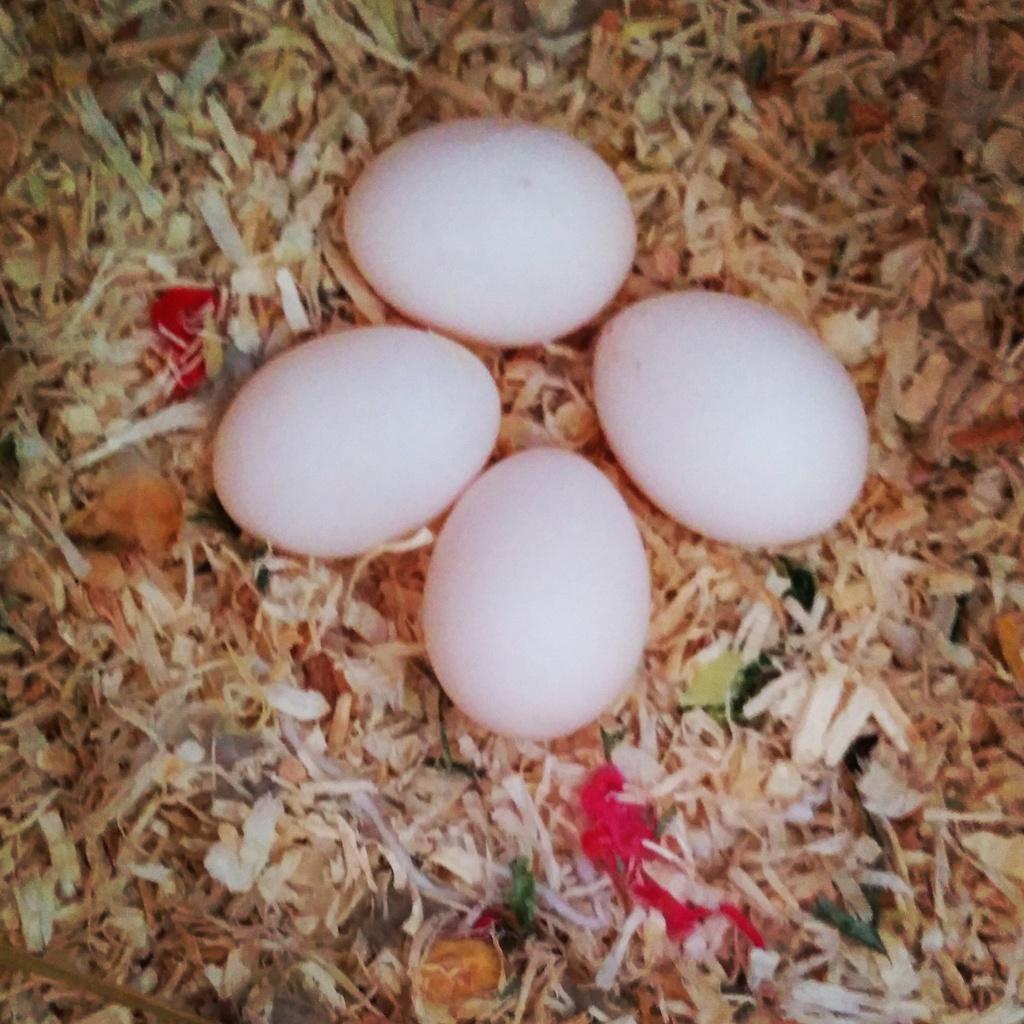Can you describe this image briefly? This image consists of four eggs. At the bottom, it looks like grass. 